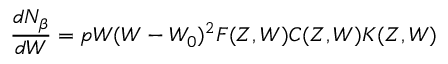Convert formula to latex. <formula><loc_0><loc_0><loc_500><loc_500>\frac { d N _ { \beta } } { d W } = p W ( W - W _ { 0 } ) ^ { 2 } F ( Z , W ) C ( Z , W ) K ( Z , W )</formula> 